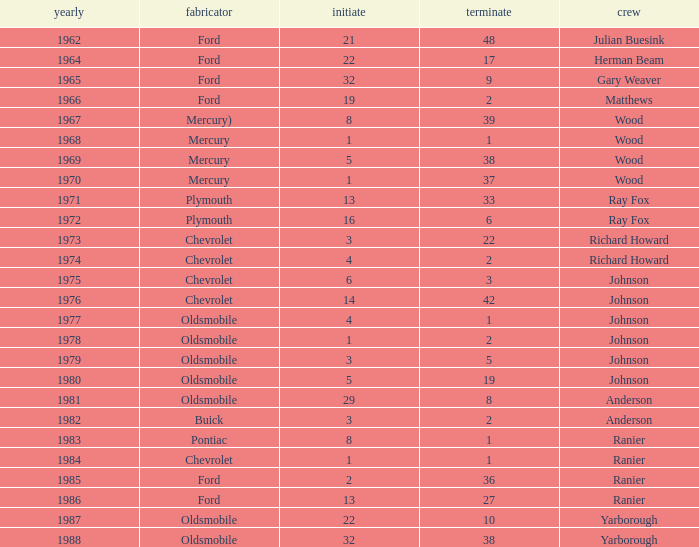Who was the maufacturer of the vehicle during the race where Cale Yarborough started at 19 and finished earlier than 42? Ford. 